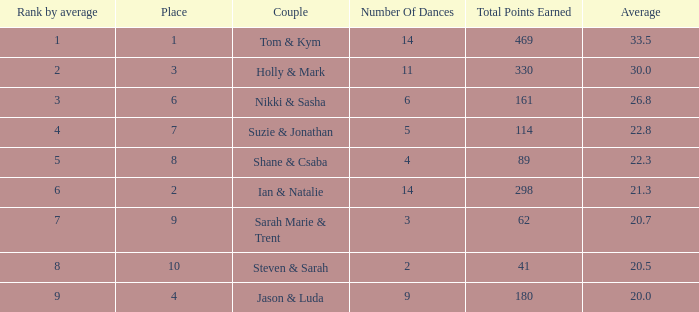What was the name of the couple if the number of dances is 6? Nikki & Sasha. 